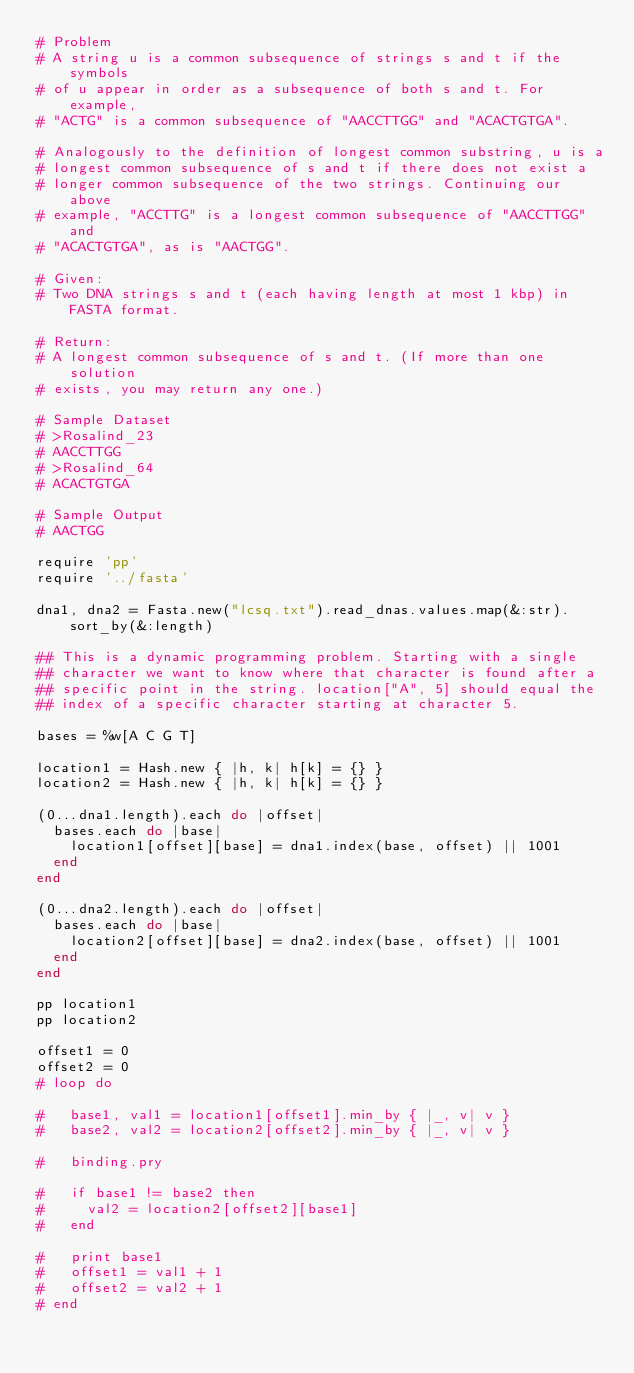Convert code to text. <code><loc_0><loc_0><loc_500><loc_500><_Ruby_># Problem
# A string u is a common subsequence of strings s and t if the symbols
# of u appear in order as a subsequence of both s and t. For example,
# "ACTG" is a common subsequence of "AACCTTGG" and "ACACTGTGA".

# Analogously to the definition of longest common substring, u is a
# longest common subsequence of s and t if there does not exist a
# longer common subsequence of the two strings. Continuing our above
# example, "ACCTTG" is a longest common subsequence of "AACCTTGG" and
# "ACACTGTGA", as is "AACTGG".

# Given:
# Two DNA strings s and t (each having length at most 1 kbp) in FASTA format.

# Return:
# A longest common subsequence of s and t. (If more than one solution
# exists, you may return any one.)

# Sample Dataset
# >Rosalind_23
# AACCTTGG
# >Rosalind_64
# ACACTGTGA

# Sample Output
# AACTGG

require 'pp'
require '../fasta'

dna1, dna2 = Fasta.new("lcsq.txt").read_dnas.values.map(&:str).sort_by(&:length)

## This is a dynamic programming problem. Starting with a single
## character we want to know where that character is found after a
## specific point in the string. location["A", 5] should equal the
## index of a specific character starting at character 5.

bases = %w[A C G T]

location1 = Hash.new { |h, k| h[k] = {} }
location2 = Hash.new { |h, k| h[k] = {} }

(0...dna1.length).each do |offset|
  bases.each do |base|
    location1[offset][base] = dna1.index(base, offset) || 1001
  end
end

(0...dna2.length).each do |offset|
  bases.each do |base|
    location2[offset][base] = dna2.index(base, offset) || 1001
  end
end

pp location1
pp location2

offset1 = 0
offset2 = 0
# loop do

#   base1, val1 = location1[offset1].min_by { |_, v| v }
#   base2, val2 = location2[offset2].min_by { |_, v| v }

#   binding.pry

#   if base1 != base2 then
#     val2 = location2[offset2][base1]
#   end

#   print base1
#   offset1 = val1 + 1
#   offset2 = val2 + 1
# end
</code> 